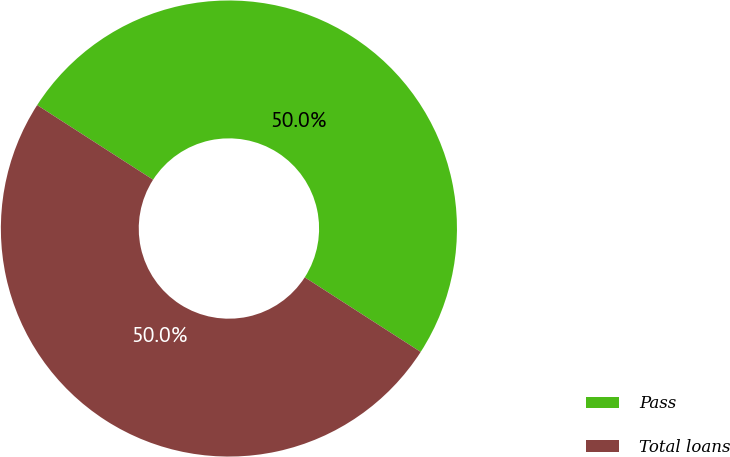Convert chart. <chart><loc_0><loc_0><loc_500><loc_500><pie_chart><fcel>Pass<fcel>Total loans<nl><fcel>50.0%<fcel>50.0%<nl></chart> 